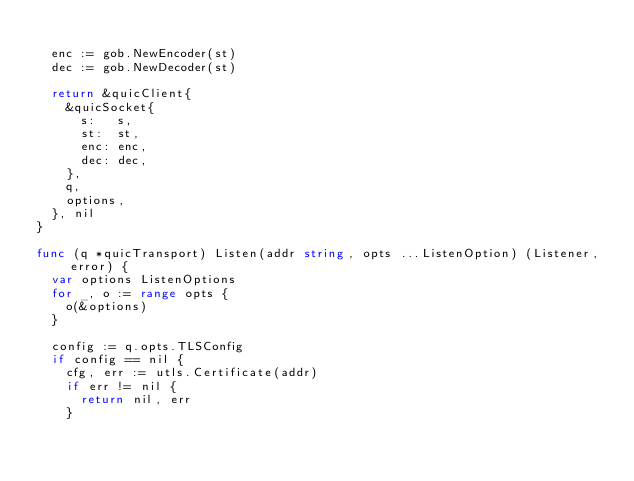Convert code to text. <code><loc_0><loc_0><loc_500><loc_500><_Go_>
	enc := gob.NewEncoder(st)
	dec := gob.NewDecoder(st)

	return &quicClient{
		&quicSocket{
			s:   s,
			st:  st,
			enc: enc,
			dec: dec,
		},
		q,
		options,
	}, nil
}

func (q *quicTransport) Listen(addr string, opts ...ListenOption) (Listener, error) {
	var options ListenOptions
	for _, o := range opts {
		o(&options)
	}

	config := q.opts.TLSConfig
	if config == nil {
		cfg, err := utls.Certificate(addr)
		if err != nil {
			return nil, err
		}</code> 